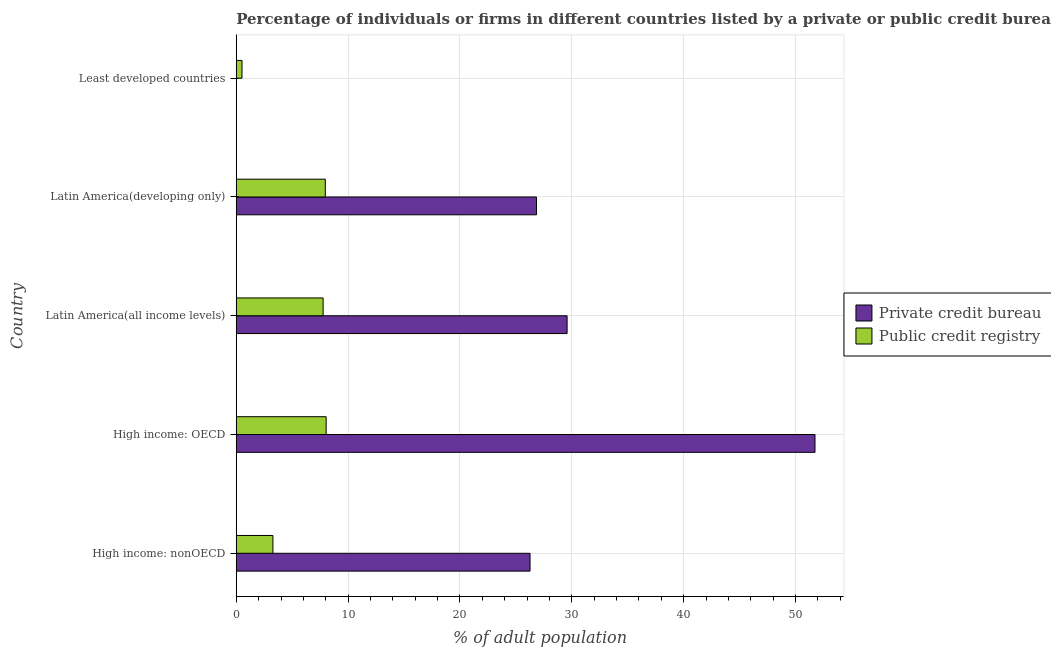How many different coloured bars are there?
Keep it short and to the point. 2. Are the number of bars per tick equal to the number of legend labels?
Make the answer very short. Yes. How many bars are there on the 3rd tick from the top?
Offer a terse response. 2. How many bars are there on the 1st tick from the bottom?
Ensure brevity in your answer.  2. What is the label of the 2nd group of bars from the top?
Offer a terse response. Latin America(developing only). In how many cases, is the number of bars for a given country not equal to the number of legend labels?
Give a very brief answer. 0. What is the percentage of firms listed by public credit bureau in Latin America(developing only)?
Your response must be concise. 7.96. Across all countries, what is the maximum percentage of firms listed by public credit bureau?
Offer a very short reply. 8.04. Across all countries, what is the minimum percentage of firms listed by public credit bureau?
Offer a terse response. 0.51. In which country was the percentage of firms listed by private credit bureau maximum?
Provide a succinct answer. High income: OECD. In which country was the percentage of firms listed by public credit bureau minimum?
Make the answer very short. Least developed countries. What is the total percentage of firms listed by private credit bureau in the graph?
Provide a succinct answer. 134.44. What is the difference between the percentage of firms listed by private credit bureau in Latin America(all income levels) and that in Least developed countries?
Provide a succinct answer. 29.57. What is the difference between the percentage of firms listed by private credit bureau in Least developed countries and the percentage of firms listed by public credit bureau in High income: OECD?
Provide a succinct answer. -8.03. What is the average percentage of firms listed by private credit bureau per country?
Keep it short and to the point. 26.89. What is the difference between the percentage of firms listed by private credit bureau and percentage of firms listed by public credit bureau in Least developed countries?
Keep it short and to the point. -0.51. In how many countries, is the percentage of firms listed by public credit bureau greater than 2 %?
Provide a short and direct response. 4. What is the ratio of the percentage of firms listed by public credit bureau in High income: OECD to that in Latin America(all income levels)?
Your response must be concise. 1.03. Is the percentage of firms listed by private credit bureau in Latin America(developing only) less than that in Least developed countries?
Provide a succinct answer. No. Is the difference between the percentage of firms listed by private credit bureau in High income: nonOECD and Latin America(all income levels) greater than the difference between the percentage of firms listed by public credit bureau in High income: nonOECD and Latin America(all income levels)?
Provide a short and direct response. Yes. What is the difference between the highest and the second highest percentage of firms listed by private credit bureau?
Provide a short and direct response. 22.16. What is the difference between the highest and the lowest percentage of firms listed by private credit bureau?
Give a very brief answer. 51.74. What does the 2nd bar from the top in Latin America(developing only) represents?
Offer a very short reply. Private credit bureau. What does the 2nd bar from the bottom in High income: nonOECD represents?
Offer a terse response. Public credit registry. How many bars are there?
Offer a very short reply. 10. Are all the bars in the graph horizontal?
Your answer should be compact. Yes. How many countries are there in the graph?
Give a very brief answer. 5. Does the graph contain any zero values?
Make the answer very short. No. Does the graph contain grids?
Make the answer very short. Yes. How are the legend labels stacked?
Your answer should be very brief. Vertical. What is the title of the graph?
Ensure brevity in your answer.  Percentage of individuals or firms in different countries listed by a private or public credit bureau. Does "Arms exports" appear as one of the legend labels in the graph?
Give a very brief answer. No. What is the label or title of the X-axis?
Offer a very short reply. % of adult population. What is the label or title of the Y-axis?
Your response must be concise. Country. What is the % of adult population in Private credit bureau in High income: nonOECD?
Provide a succinct answer. 26.27. What is the % of adult population in Public credit registry in High income: nonOECD?
Your answer should be very brief. 3.28. What is the % of adult population of Private credit bureau in High income: OECD?
Make the answer very short. 51.74. What is the % of adult population in Public credit registry in High income: OECD?
Give a very brief answer. 8.04. What is the % of adult population in Private credit bureau in Latin America(all income levels)?
Offer a very short reply. 29.58. What is the % of adult population in Public credit registry in Latin America(all income levels)?
Give a very brief answer. 7.77. What is the % of adult population in Private credit bureau in Latin America(developing only)?
Make the answer very short. 26.84. What is the % of adult population in Public credit registry in Latin America(developing only)?
Keep it short and to the point. 7.96. What is the % of adult population of Private credit bureau in Least developed countries?
Offer a very short reply. 0. What is the % of adult population of Public credit registry in Least developed countries?
Ensure brevity in your answer.  0.51. Across all countries, what is the maximum % of adult population in Private credit bureau?
Keep it short and to the point. 51.74. Across all countries, what is the maximum % of adult population in Public credit registry?
Offer a terse response. 8.04. Across all countries, what is the minimum % of adult population in Private credit bureau?
Keep it short and to the point. 0. Across all countries, what is the minimum % of adult population of Public credit registry?
Ensure brevity in your answer.  0.51. What is the total % of adult population of Private credit bureau in the graph?
Provide a short and direct response. 134.44. What is the total % of adult population of Public credit registry in the graph?
Offer a terse response. 27.56. What is the difference between the % of adult population in Private credit bureau in High income: nonOECD and that in High income: OECD?
Offer a very short reply. -25.48. What is the difference between the % of adult population of Public credit registry in High income: nonOECD and that in High income: OECD?
Keep it short and to the point. -4.76. What is the difference between the % of adult population of Private credit bureau in High income: nonOECD and that in Latin America(all income levels)?
Provide a short and direct response. -3.31. What is the difference between the % of adult population of Public credit registry in High income: nonOECD and that in Latin America(all income levels)?
Offer a very short reply. -4.49. What is the difference between the % of adult population in Private credit bureau in High income: nonOECD and that in Latin America(developing only)?
Provide a short and direct response. -0.58. What is the difference between the % of adult population in Public credit registry in High income: nonOECD and that in Latin America(developing only)?
Provide a succinct answer. -4.68. What is the difference between the % of adult population of Private credit bureau in High income: nonOECD and that in Least developed countries?
Provide a succinct answer. 26.26. What is the difference between the % of adult population in Public credit registry in High income: nonOECD and that in Least developed countries?
Your response must be concise. 2.76. What is the difference between the % of adult population of Private credit bureau in High income: OECD and that in Latin America(all income levels)?
Offer a very short reply. 22.16. What is the difference between the % of adult population in Public credit registry in High income: OECD and that in Latin America(all income levels)?
Give a very brief answer. 0.27. What is the difference between the % of adult population in Private credit bureau in High income: OECD and that in Latin America(developing only)?
Your answer should be compact. 24.9. What is the difference between the % of adult population of Public credit registry in High income: OECD and that in Latin America(developing only)?
Ensure brevity in your answer.  0.07. What is the difference between the % of adult population of Private credit bureau in High income: OECD and that in Least developed countries?
Your answer should be compact. 51.74. What is the difference between the % of adult population in Public credit registry in High income: OECD and that in Least developed countries?
Make the answer very short. 7.52. What is the difference between the % of adult population of Private credit bureau in Latin America(all income levels) and that in Latin America(developing only)?
Offer a very short reply. 2.74. What is the difference between the % of adult population of Public credit registry in Latin America(all income levels) and that in Latin America(developing only)?
Give a very brief answer. -0.2. What is the difference between the % of adult population in Private credit bureau in Latin America(all income levels) and that in Least developed countries?
Offer a terse response. 29.58. What is the difference between the % of adult population in Public credit registry in Latin America(all income levels) and that in Least developed countries?
Your answer should be very brief. 7.25. What is the difference between the % of adult population of Private credit bureau in Latin America(developing only) and that in Least developed countries?
Give a very brief answer. 26.84. What is the difference between the % of adult population in Public credit registry in Latin America(developing only) and that in Least developed countries?
Keep it short and to the point. 7.45. What is the difference between the % of adult population of Private credit bureau in High income: nonOECD and the % of adult population of Public credit registry in High income: OECD?
Your answer should be very brief. 18.23. What is the difference between the % of adult population of Private credit bureau in High income: nonOECD and the % of adult population of Public credit registry in Latin America(all income levels)?
Ensure brevity in your answer.  18.5. What is the difference between the % of adult population in Private credit bureau in High income: nonOECD and the % of adult population in Public credit registry in Latin America(developing only)?
Ensure brevity in your answer.  18.3. What is the difference between the % of adult population of Private credit bureau in High income: nonOECD and the % of adult population of Public credit registry in Least developed countries?
Offer a very short reply. 25.75. What is the difference between the % of adult population of Private credit bureau in High income: OECD and the % of adult population of Public credit registry in Latin America(all income levels)?
Give a very brief answer. 43.98. What is the difference between the % of adult population of Private credit bureau in High income: OECD and the % of adult population of Public credit registry in Latin America(developing only)?
Give a very brief answer. 43.78. What is the difference between the % of adult population of Private credit bureau in High income: OECD and the % of adult population of Public credit registry in Least developed countries?
Your response must be concise. 51.23. What is the difference between the % of adult population of Private credit bureau in Latin America(all income levels) and the % of adult population of Public credit registry in Latin America(developing only)?
Provide a succinct answer. 21.62. What is the difference between the % of adult population of Private credit bureau in Latin America(all income levels) and the % of adult population of Public credit registry in Least developed countries?
Give a very brief answer. 29.07. What is the difference between the % of adult population in Private credit bureau in Latin America(developing only) and the % of adult population in Public credit registry in Least developed countries?
Ensure brevity in your answer.  26.33. What is the average % of adult population of Private credit bureau per country?
Offer a very short reply. 26.89. What is the average % of adult population of Public credit registry per country?
Offer a very short reply. 5.51. What is the difference between the % of adult population of Private credit bureau and % of adult population of Public credit registry in High income: nonOECD?
Your answer should be very brief. 22.99. What is the difference between the % of adult population in Private credit bureau and % of adult population in Public credit registry in High income: OECD?
Ensure brevity in your answer.  43.71. What is the difference between the % of adult population in Private credit bureau and % of adult population in Public credit registry in Latin America(all income levels)?
Offer a very short reply. 21.81. What is the difference between the % of adult population of Private credit bureau and % of adult population of Public credit registry in Latin America(developing only)?
Provide a succinct answer. 18.88. What is the difference between the % of adult population in Private credit bureau and % of adult population in Public credit registry in Least developed countries?
Your response must be concise. -0.51. What is the ratio of the % of adult population of Private credit bureau in High income: nonOECD to that in High income: OECD?
Give a very brief answer. 0.51. What is the ratio of the % of adult population in Public credit registry in High income: nonOECD to that in High income: OECD?
Provide a short and direct response. 0.41. What is the ratio of the % of adult population in Private credit bureau in High income: nonOECD to that in Latin America(all income levels)?
Your answer should be compact. 0.89. What is the ratio of the % of adult population in Public credit registry in High income: nonOECD to that in Latin America(all income levels)?
Keep it short and to the point. 0.42. What is the ratio of the % of adult population of Private credit bureau in High income: nonOECD to that in Latin America(developing only)?
Provide a succinct answer. 0.98. What is the ratio of the % of adult population of Public credit registry in High income: nonOECD to that in Latin America(developing only)?
Ensure brevity in your answer.  0.41. What is the ratio of the % of adult population in Private credit bureau in High income: nonOECD to that in Least developed countries?
Make the answer very short. 5647.02. What is the ratio of the % of adult population of Public credit registry in High income: nonOECD to that in Least developed countries?
Keep it short and to the point. 6.38. What is the ratio of the % of adult population in Private credit bureau in High income: OECD to that in Latin America(all income levels)?
Offer a terse response. 1.75. What is the ratio of the % of adult population of Public credit registry in High income: OECD to that in Latin America(all income levels)?
Provide a short and direct response. 1.03. What is the ratio of the % of adult population of Private credit bureau in High income: OECD to that in Latin America(developing only)?
Make the answer very short. 1.93. What is the ratio of the % of adult population in Public credit registry in High income: OECD to that in Latin America(developing only)?
Give a very brief answer. 1.01. What is the ratio of the % of adult population in Private credit bureau in High income: OECD to that in Least developed countries?
Provide a succinct answer. 1.11e+04. What is the ratio of the % of adult population of Public credit registry in High income: OECD to that in Least developed countries?
Your answer should be very brief. 15.64. What is the ratio of the % of adult population in Private credit bureau in Latin America(all income levels) to that in Latin America(developing only)?
Provide a short and direct response. 1.1. What is the ratio of the % of adult population in Public credit registry in Latin America(all income levels) to that in Latin America(developing only)?
Ensure brevity in your answer.  0.98. What is the ratio of the % of adult population in Private credit bureau in Latin America(all income levels) to that in Least developed countries?
Keep it short and to the point. 6359.7. What is the ratio of the % of adult population of Public credit registry in Latin America(all income levels) to that in Least developed countries?
Your answer should be compact. 15.11. What is the ratio of the % of adult population of Private credit bureau in Latin America(developing only) to that in Least developed countries?
Keep it short and to the point. 5771.21. What is the ratio of the % of adult population in Public credit registry in Latin America(developing only) to that in Least developed countries?
Your answer should be very brief. 15.49. What is the difference between the highest and the second highest % of adult population of Private credit bureau?
Make the answer very short. 22.16. What is the difference between the highest and the second highest % of adult population in Public credit registry?
Provide a short and direct response. 0.07. What is the difference between the highest and the lowest % of adult population in Private credit bureau?
Your response must be concise. 51.74. What is the difference between the highest and the lowest % of adult population in Public credit registry?
Provide a short and direct response. 7.52. 